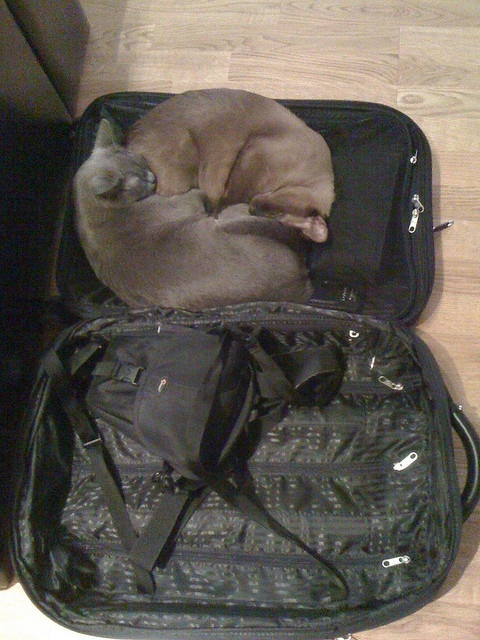Describe the objects in this image and their specific colors. I can see suitcase in maroon, gray, and black tones, cat in maroon, gray, and black tones, and cat in maroon and gray tones in this image. 